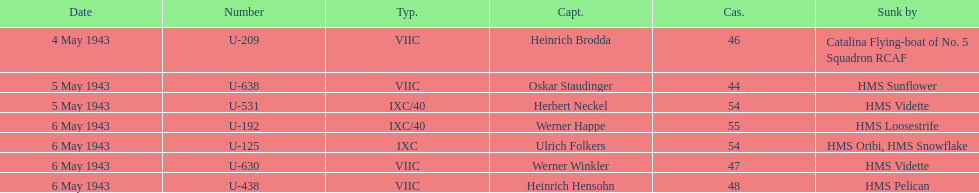How many additional casualties took place on may 6 in comparison to may 4? 158. 